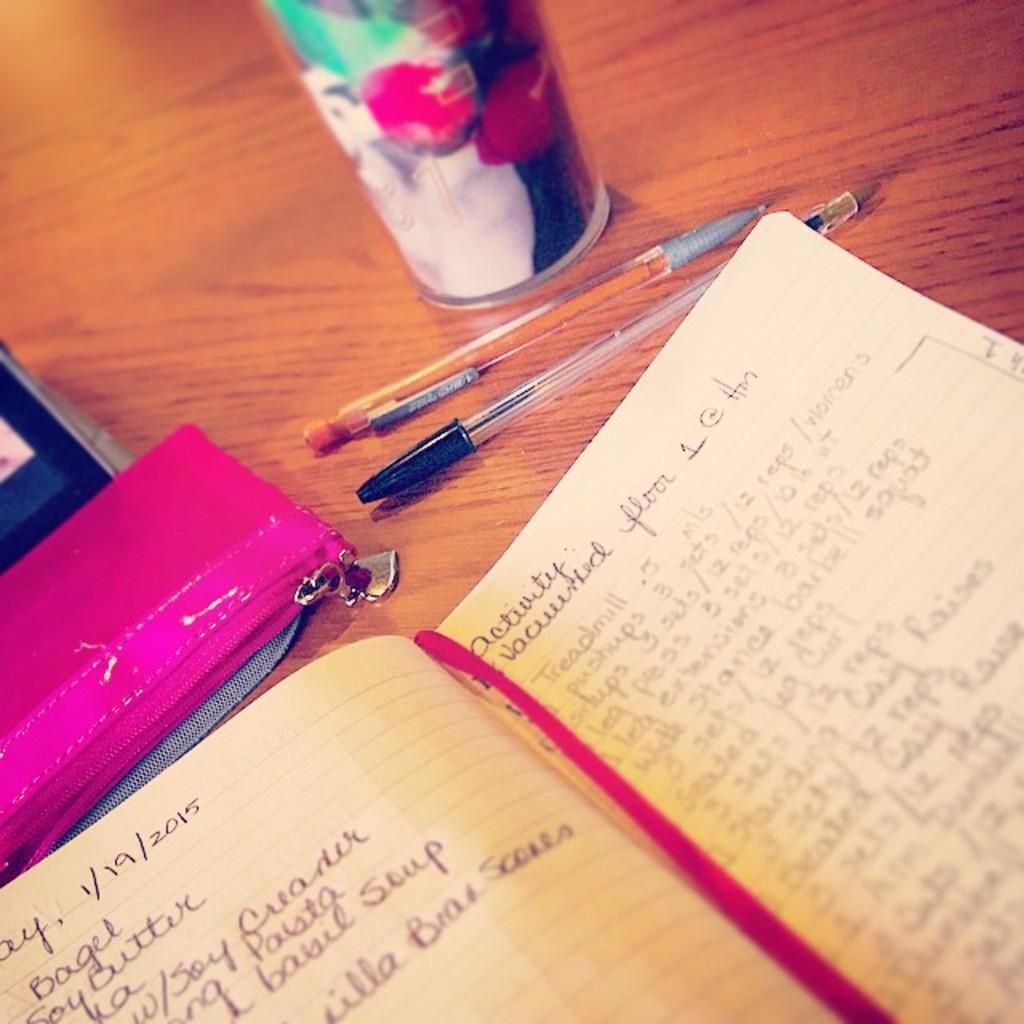In one or two sentences, can you explain what this image depicts? As we can see in the image there is a table. On table there is a book, wallet, pens and a glass. 